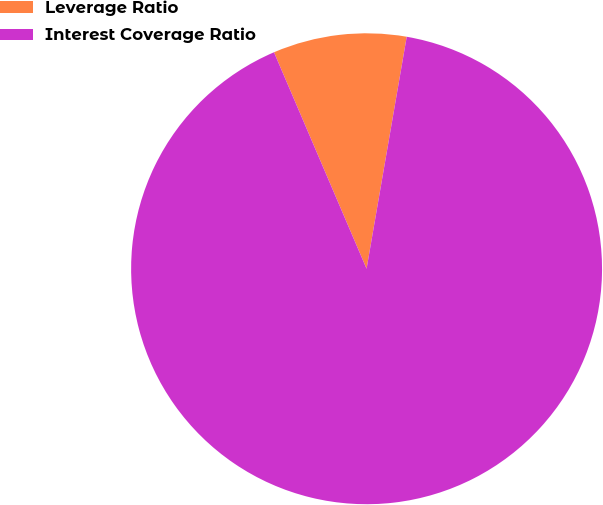Convert chart. <chart><loc_0><loc_0><loc_500><loc_500><pie_chart><fcel>Leverage Ratio<fcel>Interest Coverage Ratio<nl><fcel>9.16%<fcel>90.84%<nl></chart> 